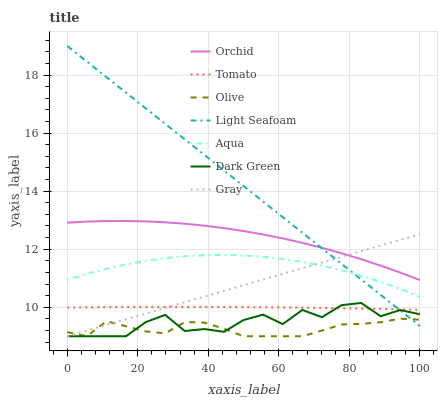Does Olive have the minimum area under the curve?
Answer yes or no. Yes. Does Light Seafoam have the maximum area under the curve?
Answer yes or no. Yes. Does Gray have the minimum area under the curve?
Answer yes or no. No. Does Gray have the maximum area under the curve?
Answer yes or no. No. Is Gray the smoothest?
Answer yes or no. Yes. Is Dark Green the roughest?
Answer yes or no. Yes. Is Aqua the smoothest?
Answer yes or no. No. Is Aqua the roughest?
Answer yes or no. No. Does Gray have the lowest value?
Answer yes or no. Yes. Does Aqua have the lowest value?
Answer yes or no. No. Does Light Seafoam have the highest value?
Answer yes or no. Yes. Does Gray have the highest value?
Answer yes or no. No. Is Olive less than Orchid?
Answer yes or no. Yes. Is Aqua greater than Dark Green?
Answer yes or no. Yes. Does Light Seafoam intersect Orchid?
Answer yes or no. Yes. Is Light Seafoam less than Orchid?
Answer yes or no. No. Is Light Seafoam greater than Orchid?
Answer yes or no. No. Does Olive intersect Orchid?
Answer yes or no. No. 